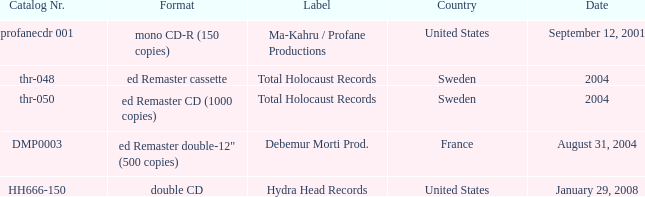Which nation possesses the catalog number thr-048 in 2004? Sweden. 